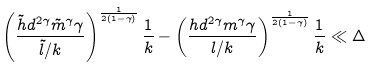<formula> <loc_0><loc_0><loc_500><loc_500>\left ( \frac { \tilde { h } d ^ { 2 \gamma } \tilde { m } ^ { \gamma } \gamma } { \tilde { l } / k } \right ) ^ { \frac { 1 } { 2 ( 1 - \gamma ) } } \frac { 1 } { k } - \left ( \frac { h d ^ { 2 \gamma } m ^ { \gamma } \gamma } { l / k } \right ) ^ { \frac { 1 } { 2 ( 1 - \gamma ) } } \frac { 1 } { k } \ll \Delta</formula> 